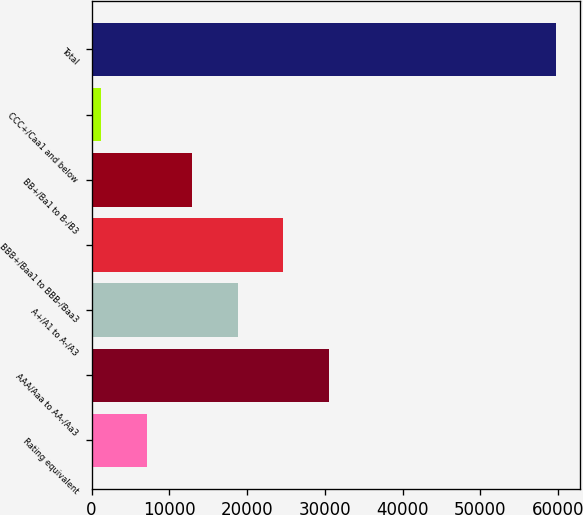Convert chart. <chart><loc_0><loc_0><loc_500><loc_500><bar_chart><fcel>Rating equivalent<fcel>AAA/Aaa to AA-/Aa3<fcel>A+/A1 to A-/A3<fcel>BBB+/Baa1 to BBB-/Baa3<fcel>BB+/Ba1 to B-/B3<fcel>CCC+/Caa1 and below<fcel>Total<nl><fcel>7129.3<fcel>30530.5<fcel>18829.9<fcel>24680.2<fcel>12979.6<fcel>1279<fcel>59782<nl></chart> 